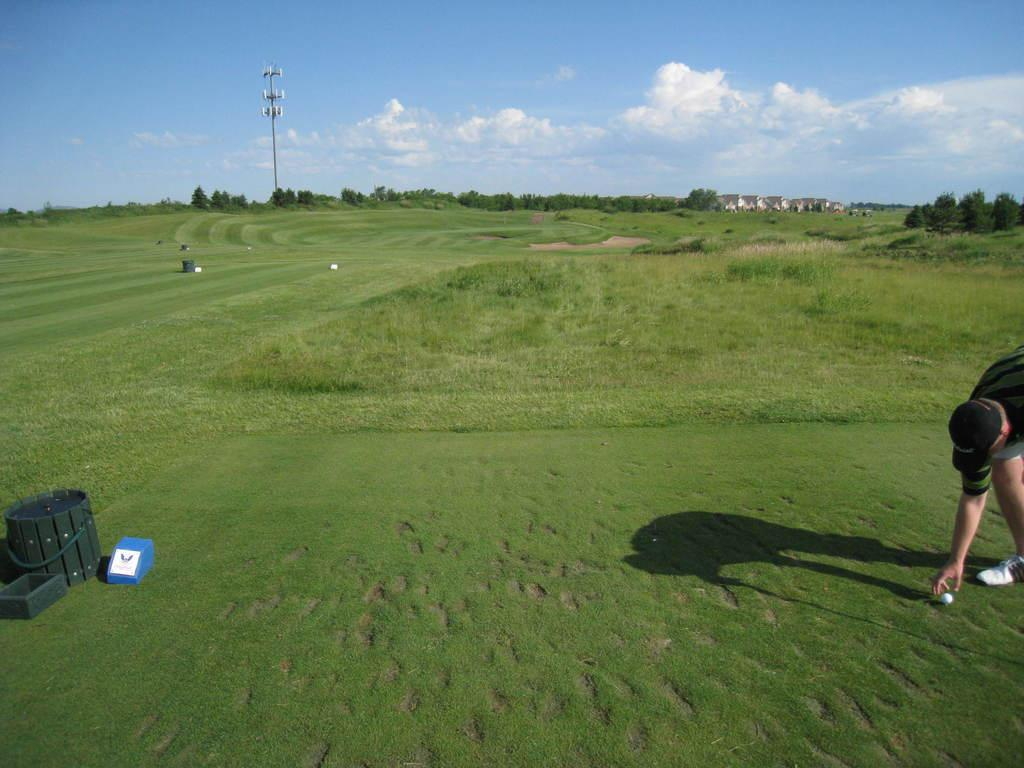What is the main subject in the image? There is a person in the image. What objects are present with the person? There is a ball, a bucket, and a box in the image. What is the color of the blue object in the image? The blue object in the image is not specified, but it is mentioned that there is a blue object present. Where are the objects located in the image? The objects are on the grass. What can be seen in the background of the image? There are objects, trees, a pole, and the sky visible in the background of the image. What is the condition of the sky in the image? The sky is visible in the background of the image, and there are clouds present. How many dogs are playing with the person in the image? There are no dogs present in the image; it only features a person and various objects. What type of frog can be seen sitting on the bucket in the image? There is no frog present in the image; it only features a person, a ball, a bucket, and a box. 